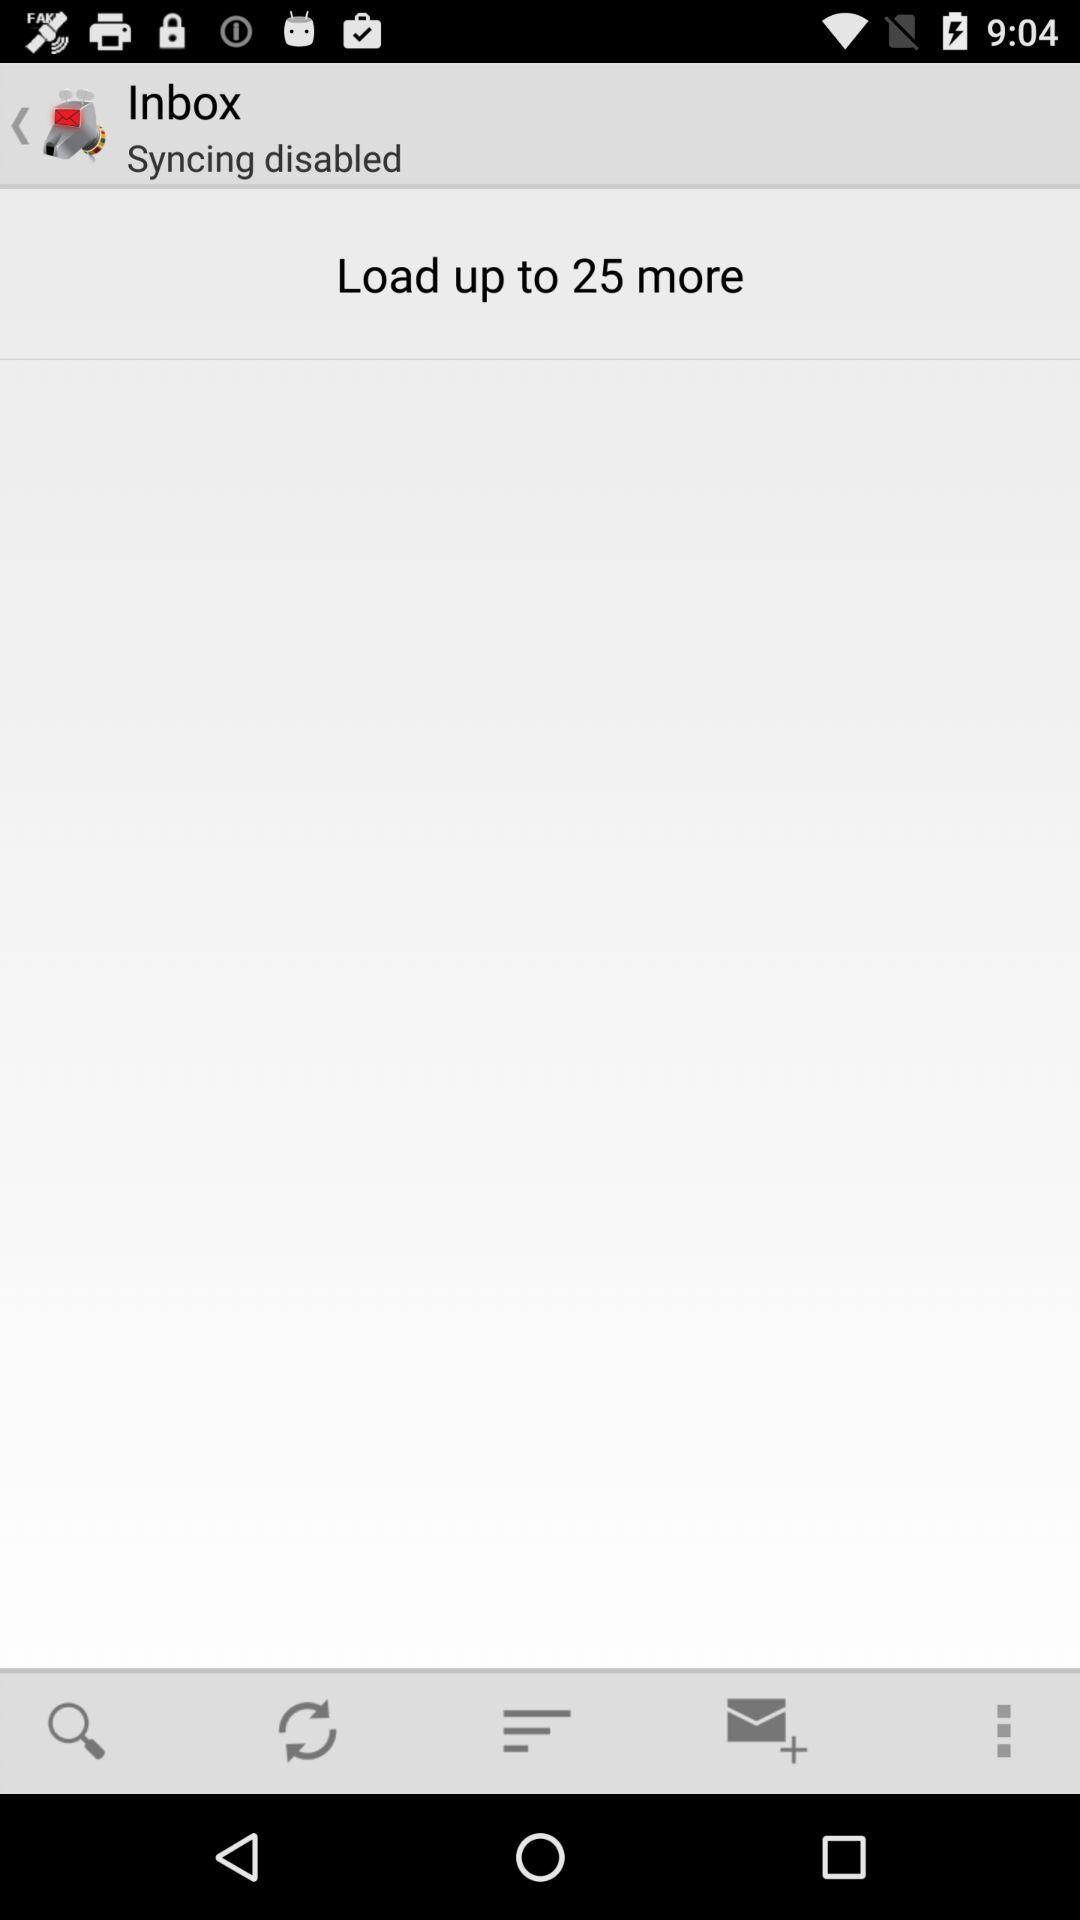How many more emails can be loaded? There are up to 25 more emails that can be loaded. 